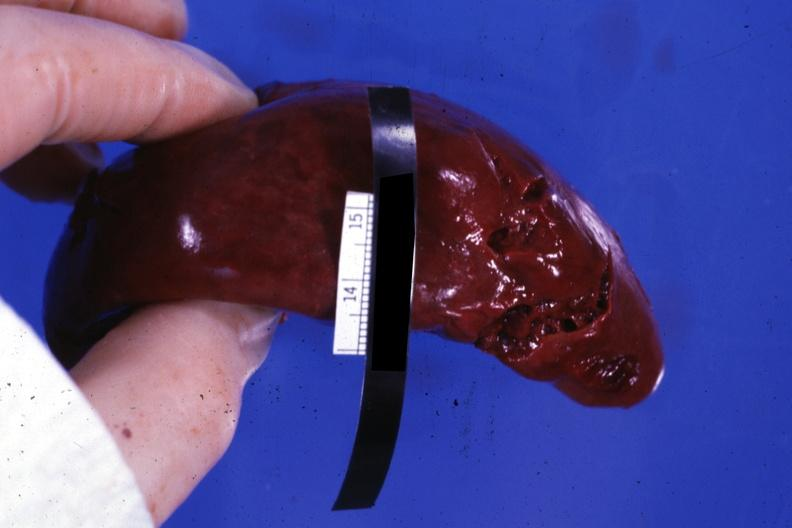s endocervical polyp present?
Answer the question using a single word or phrase. No 